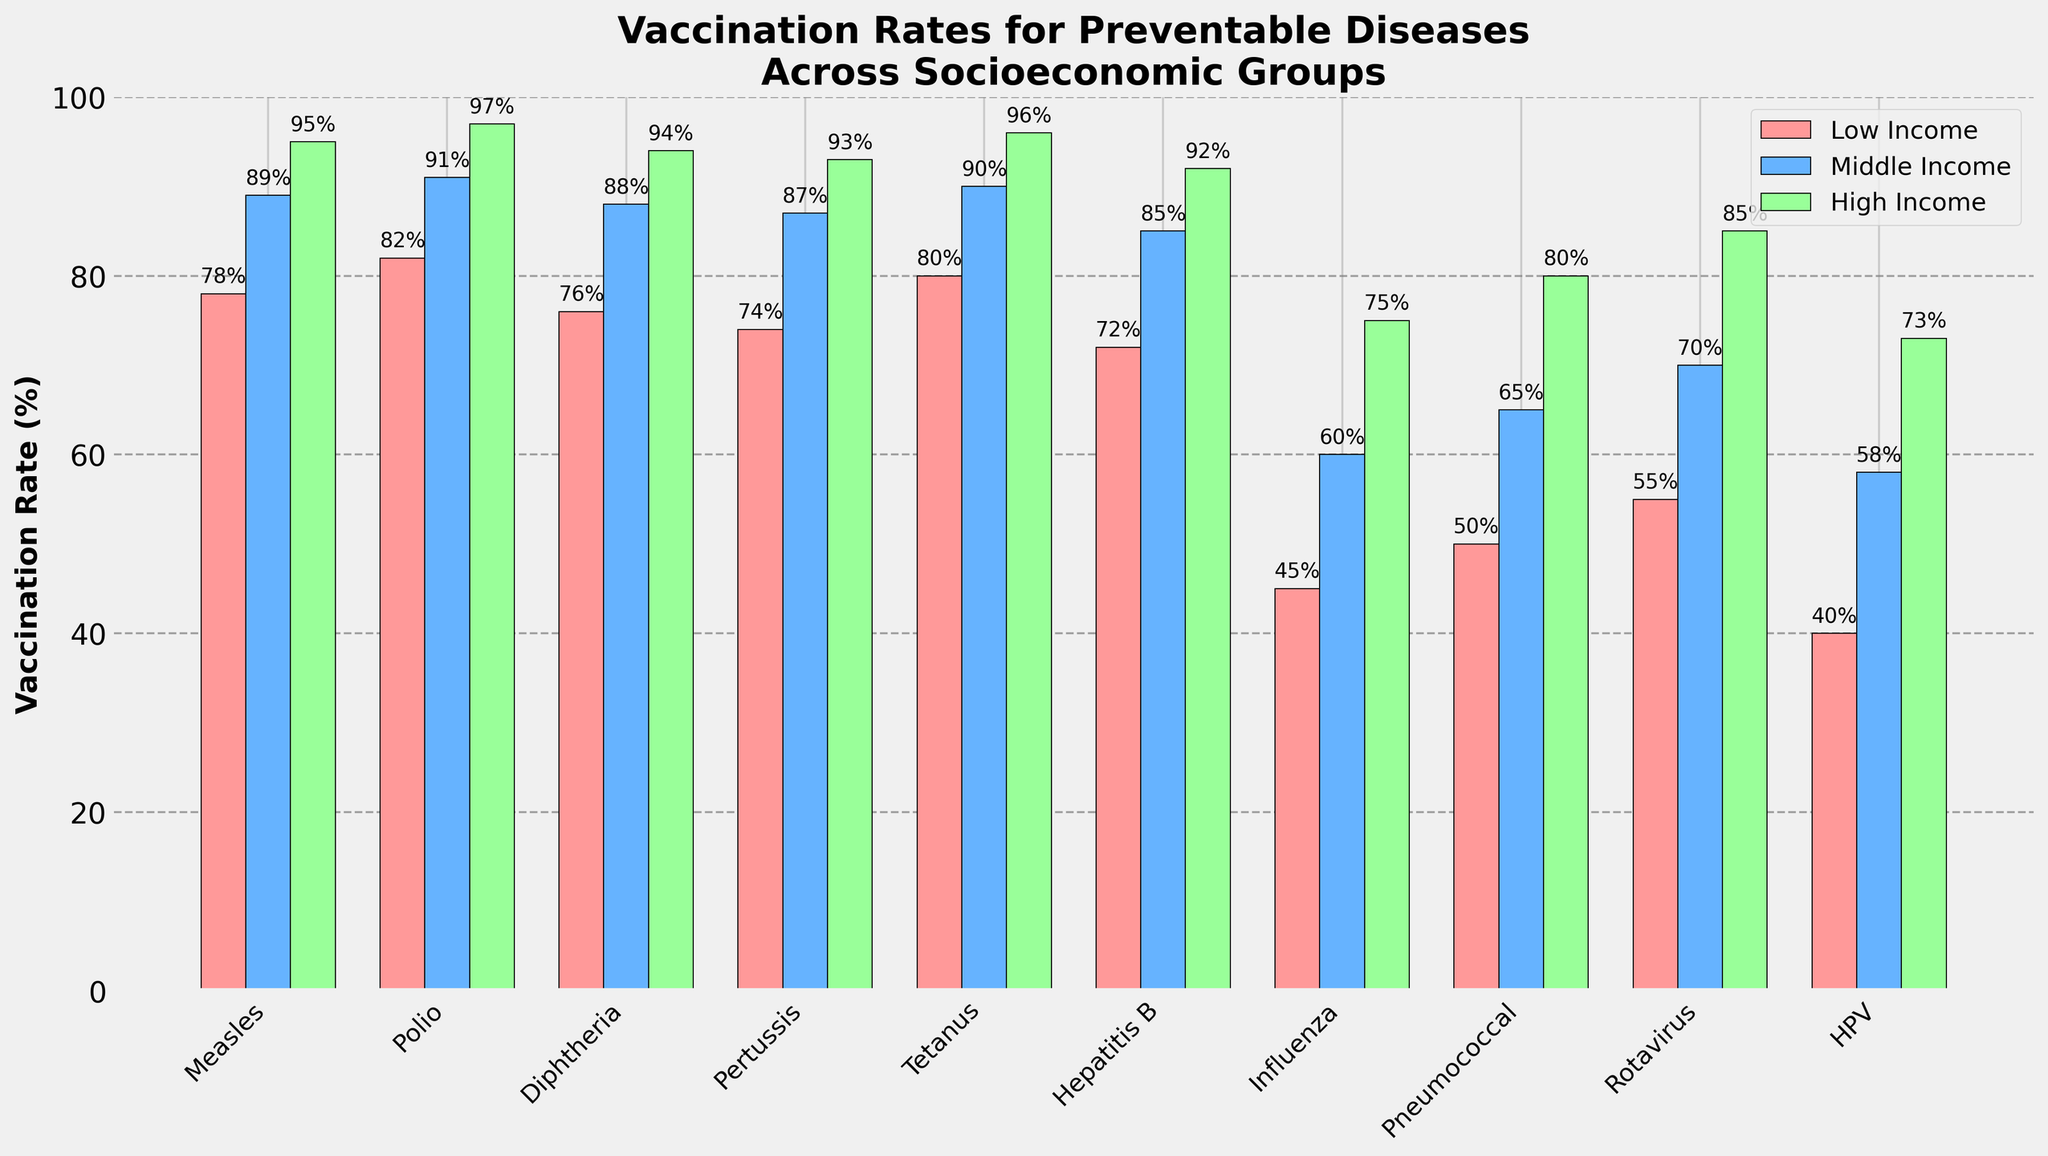Which disease has the lowest vaccination rate among low-income groups? Visually inspect the bar heights for each disease in the low-income group (red bars) and identify the shortest one. The shortest bar corresponds to the HPV vaccination rate.
Answer: HPV Which group has the highest vaccination rate for Tetanus? Compare the bar heights for Tetanus across all three groups and identify the tallest one. The tallest bar corresponds to the high-income group.
Answer: High Income What is the difference in vaccination rates for Influenza between low-income and high-income groups? Identify the heights of the bars for Influenza in both the low-income and high-income groups, which are 45% and 75% respectively. Subtract the lower value from the higher value: 75% - 45% = 30%.
Answer: 30% What is the average vaccination rate for Polio across all socioeconomic groups? Find the heights of the Polio bars for each group: 82% (low-income), 91% (middle-income), 97% (high-income). Sum these values and divide by 3 to find the average: (82 + 91 + 97) / 3 ≈ 90%.
Answer: 90% How do the vaccination rates for Diphtheria compare between middle-income and high-income groups? Compare the heights of the bars for Diphtheria in the middle-income and high-income groups. The middle-income bar is at 88%, and the high-income bar is at 94%. The high-income group's rate is 6% higher than the middle-income group's rate.
Answer: The high-income group has a 6% higher rate Which socio-economic group shows the most variability in vaccination rates across different diseases? Assess the range of vaccination rates (the difference between the highest and lowest rates) within each group. For low-income: 78% (highest) - 40% (lowest) = 38%. For middle-income: 91% (highest) - 58% (lowest) = 33%. For high-income: 97% (highest) - 73% (lowest) = 24%. The low-income group exhibits the most variability.
Answer: Low Income What proportion of diseases have a vaccination rate of at least 90% in the middle-income group? Count the number of diseases where the middle-income group's bar height is at least 90%. There are three such diseases: Tetanus, Polio, and Measles out of ten diseases total, so the proportion is 3/10 or 30%.
Answer: 30% For which diseases do the vaccination rates follow the same ranking order (low-income < middle-income < high-income) across all groups? Examine each disease to see if their vaccination rates consistently increase from low to middle to high-income groups. All diseases follow this ranking pattern: Measles, Polio, Diphtheria, Pertussis, Tetanus, Hepatitis B, Influenza, Pneumococcal, Rotavirus, and HPV.
Answer: All diseases If we consider the high-income group, which diseases have a vaccination rate greater than 90%? Identify the diseases where the high-income group's bar height is above 90%. These diseases are Measles (95%), Polio (97%), Diphtheria (94%), Pertussis (93%), Tetanus (96%), and Hepatitis B (92%).
Answer: Measles, Polio, Diphtheria, Pertussis, Tetanus, Hepatitis B 